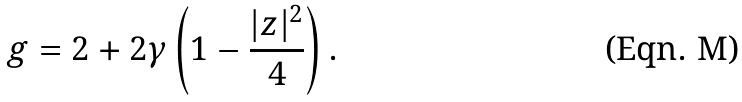Convert formula to latex. <formula><loc_0><loc_0><loc_500><loc_500>g = 2 + 2 \gamma \left ( 1 - \frac { | z | ^ { 2 } } { 4 } \right ) .</formula> 